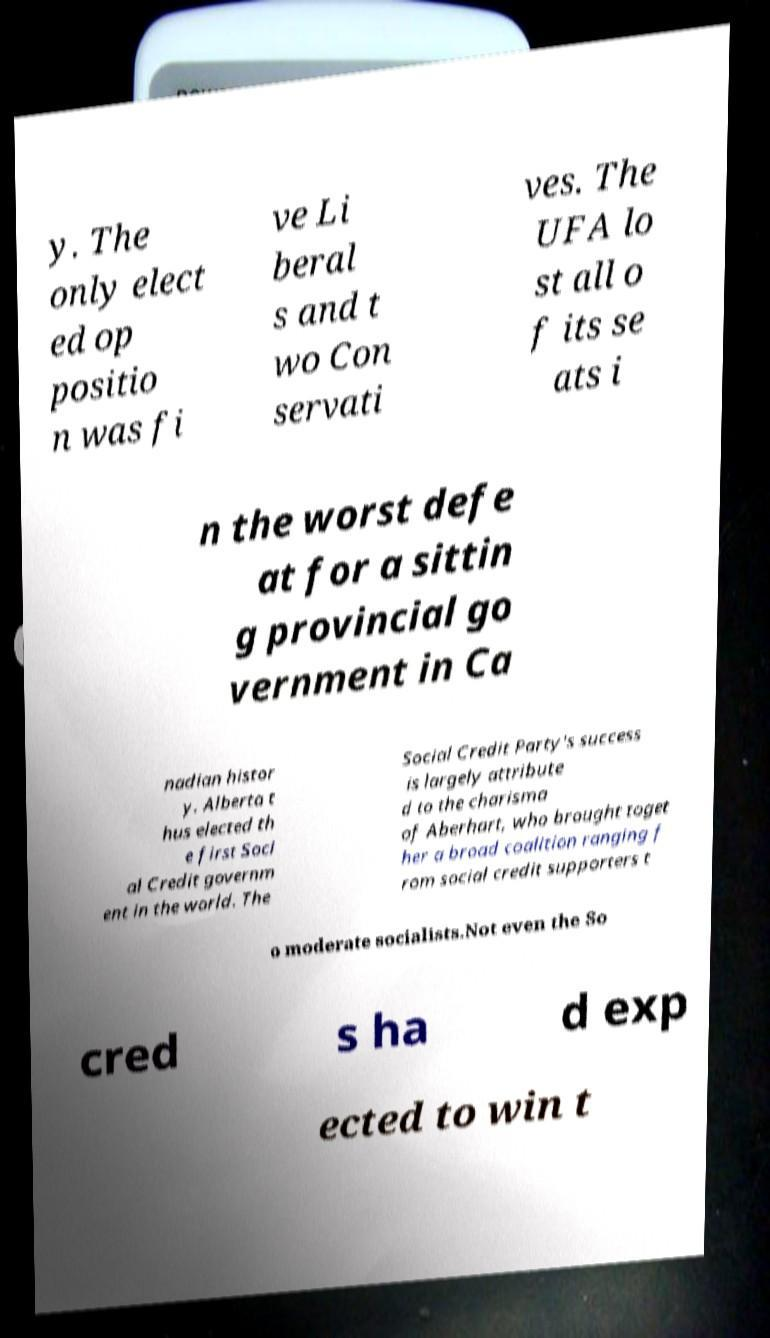I need the written content from this picture converted into text. Can you do that? y. The only elect ed op positio n was fi ve Li beral s and t wo Con servati ves. The UFA lo st all o f its se ats i n the worst defe at for a sittin g provincial go vernment in Ca nadian histor y. Alberta t hus elected th e first Soci al Credit governm ent in the world. The Social Credit Party's success is largely attribute d to the charisma of Aberhart, who brought toget her a broad coalition ranging f rom social credit supporters t o moderate socialists.Not even the So cred s ha d exp ected to win t 